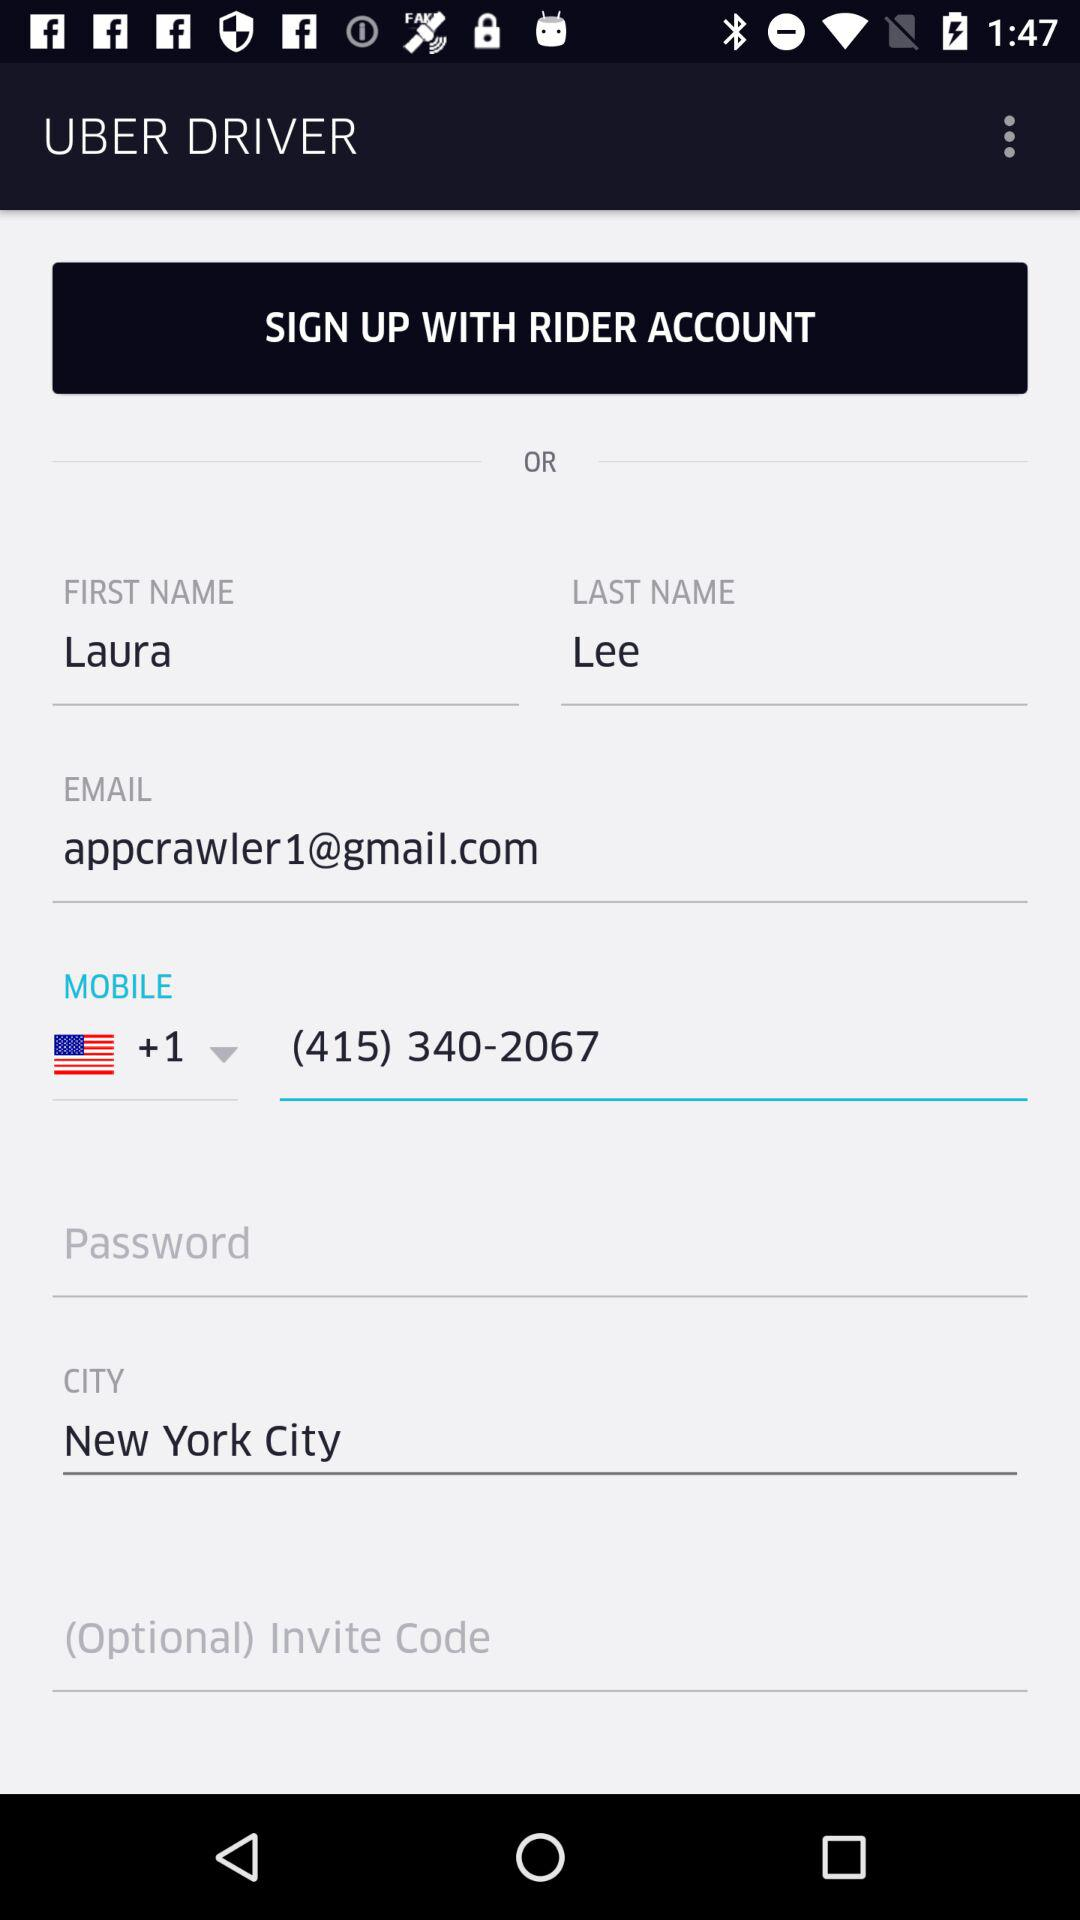What is the country code given on the screen? The given country code is +1. 